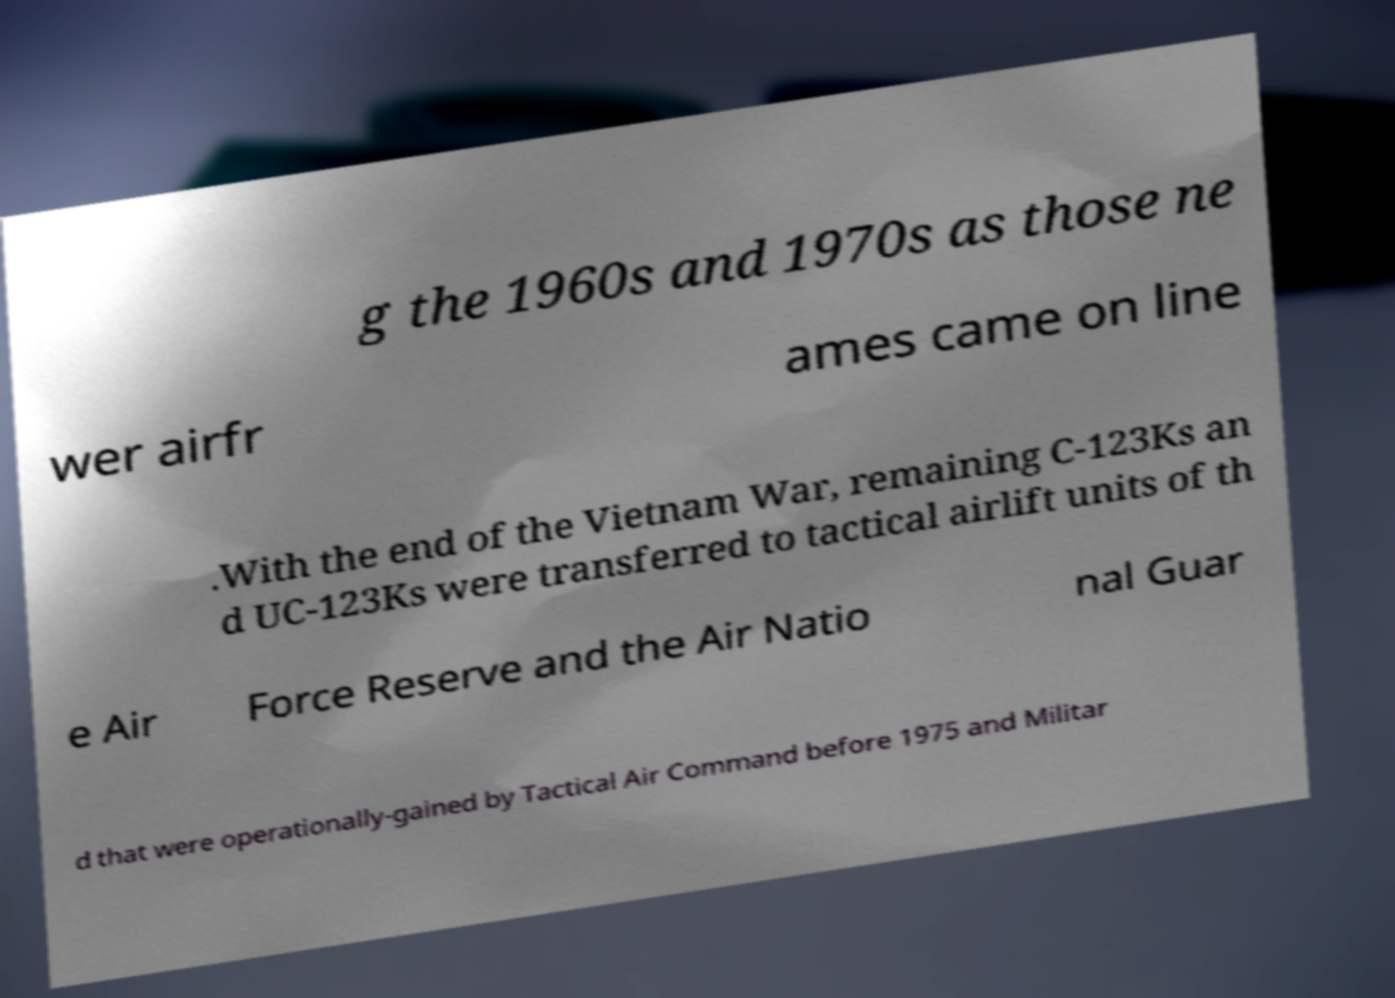Can you read and provide the text displayed in the image?This photo seems to have some interesting text. Can you extract and type it out for me? g the 1960s and 1970s as those ne wer airfr ames came on line .With the end of the Vietnam War, remaining C-123Ks an d UC-123Ks were transferred to tactical airlift units of th e Air Force Reserve and the Air Natio nal Guar d that were operationally-gained by Tactical Air Command before 1975 and Militar 